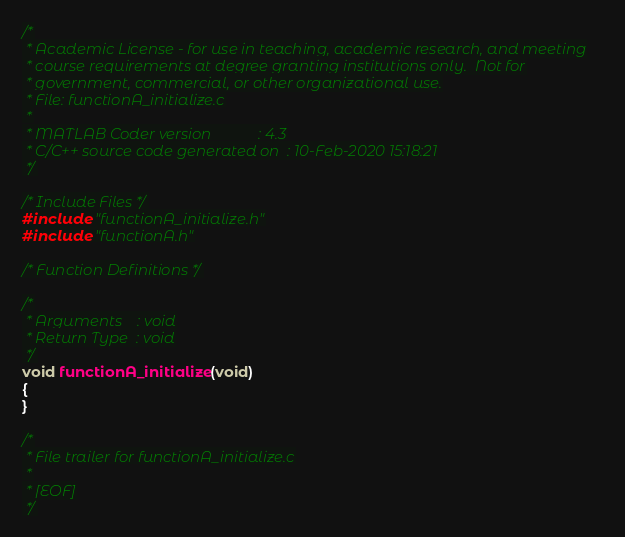<code> <loc_0><loc_0><loc_500><loc_500><_C_>/*
 * Academic License - for use in teaching, academic research, and meeting
 * course requirements at degree granting institutions only.  Not for
 * government, commercial, or other organizational use.
 * File: functionA_initialize.c
 *
 * MATLAB Coder version            : 4.3
 * C/C++ source code generated on  : 10-Feb-2020 15:18:21
 */

/* Include Files */
#include "functionA_initialize.h"
#include "functionA.h"

/* Function Definitions */

/*
 * Arguments    : void
 * Return Type  : void
 */
void functionA_initialize(void)
{
}

/*
 * File trailer for functionA_initialize.c
 *
 * [EOF]
 */
</code> 